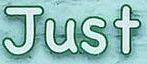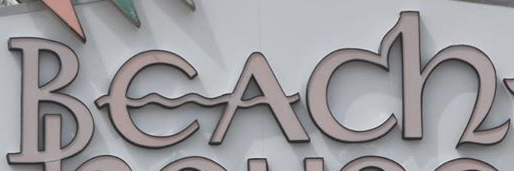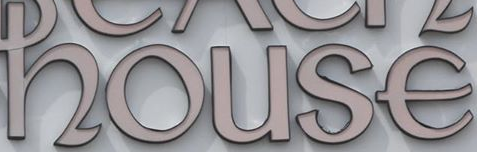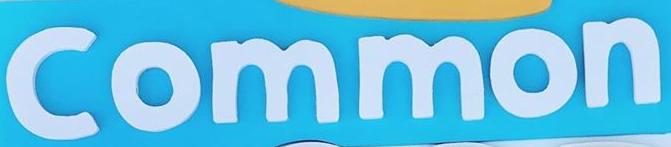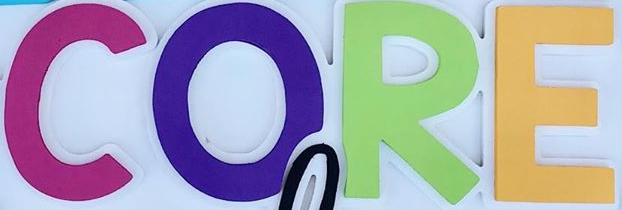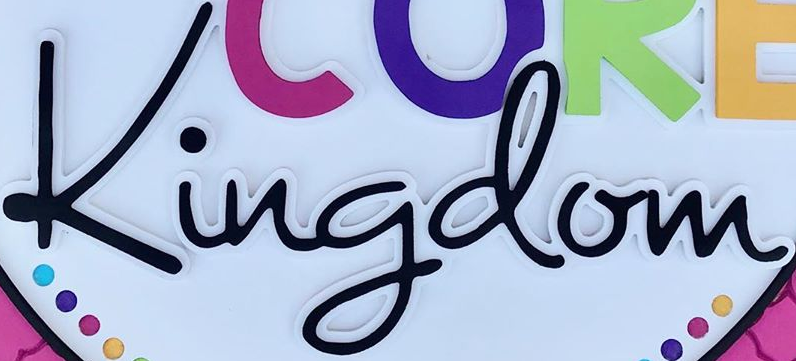What text appears in these images from left to right, separated by a semicolon? Just; Beach; house; Common; CORE; Kingdom 